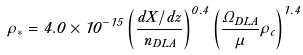<formula> <loc_0><loc_0><loc_500><loc_500>\dot { \rho } _ { * } = 4 . 0 \times 1 0 ^ { - 1 5 } \left ( \frac { d X / d z } { n _ { D L A } } \right ) ^ { 0 . 4 } \left ( \frac { \Omega _ { D L A } } { \mu } \rho _ { c } \right ) ^ { 1 . 4 }</formula> 